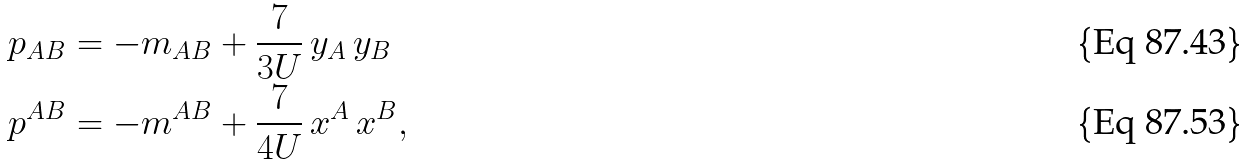Convert formula to latex. <formula><loc_0><loc_0><loc_500><loc_500>p _ { A B } & = - m _ { A B } + \frac { 7 } { 3 U } \, y _ { A } \, y _ { B } \\ p ^ { A B } & = - m ^ { A B } + \frac { 7 } { 4 U } \, x ^ { A } \, x ^ { B } ,</formula> 